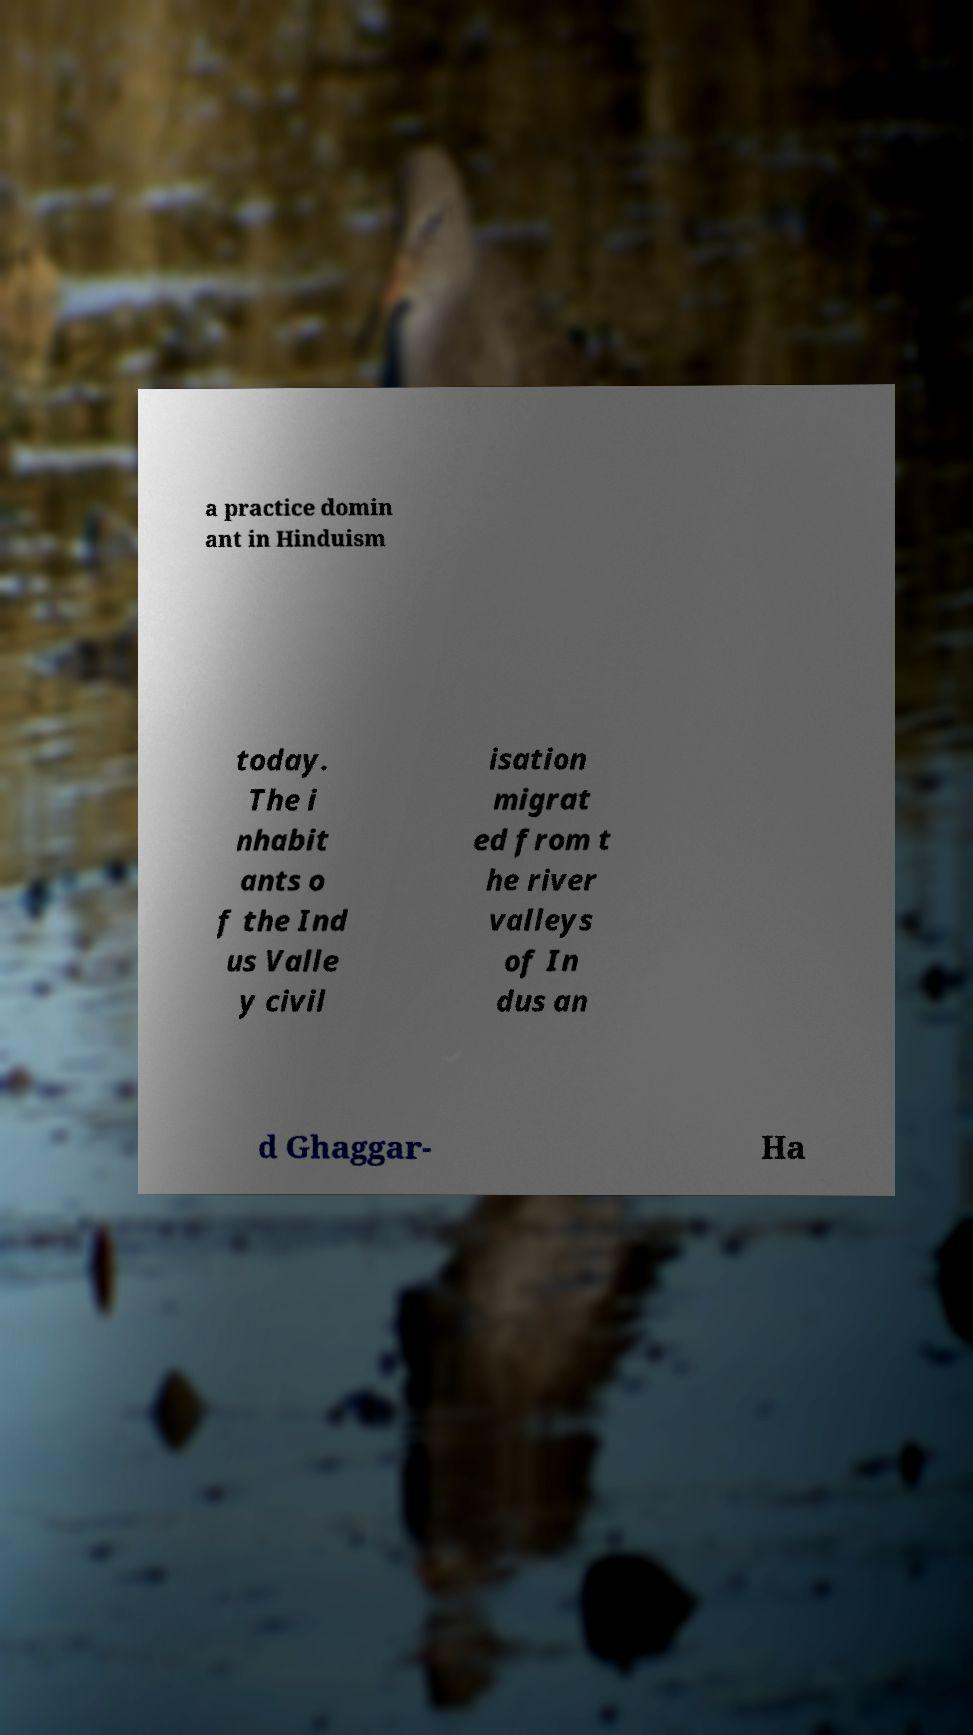Could you assist in decoding the text presented in this image and type it out clearly? a practice domin ant in Hinduism today. The i nhabit ants o f the Ind us Valle y civil isation migrat ed from t he river valleys of In dus an d Ghaggar- Ha 